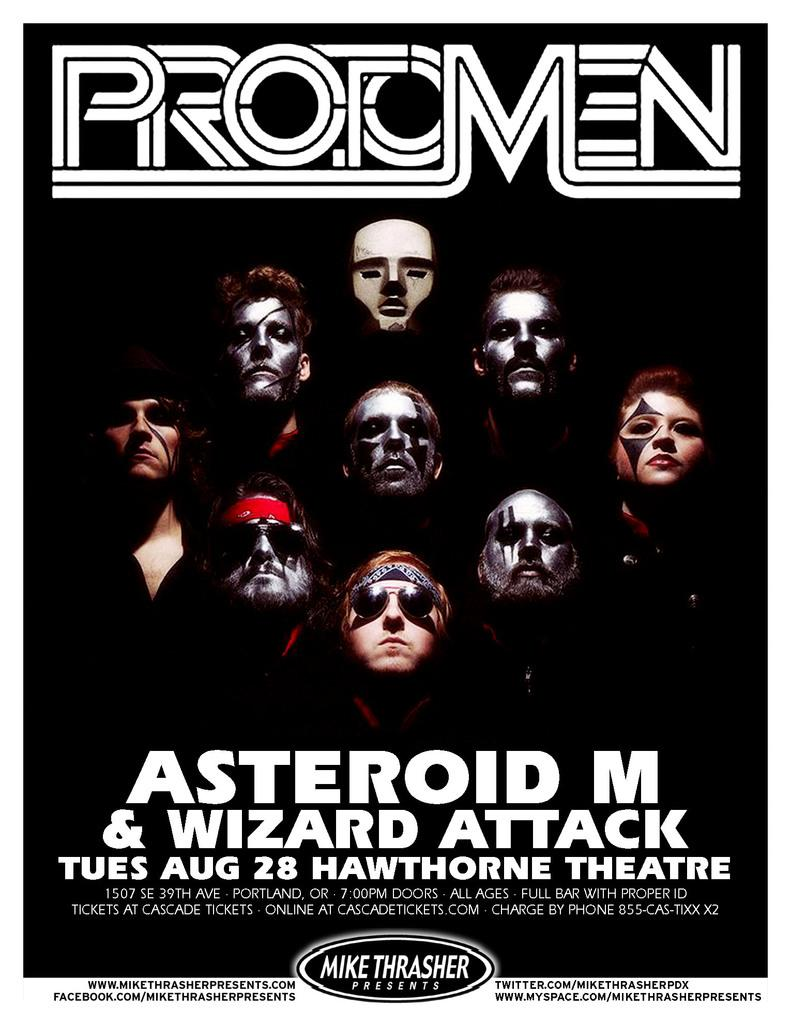Provide a one-sentence caption for the provided image. The Protomen flier is promoting their August 28 show. 